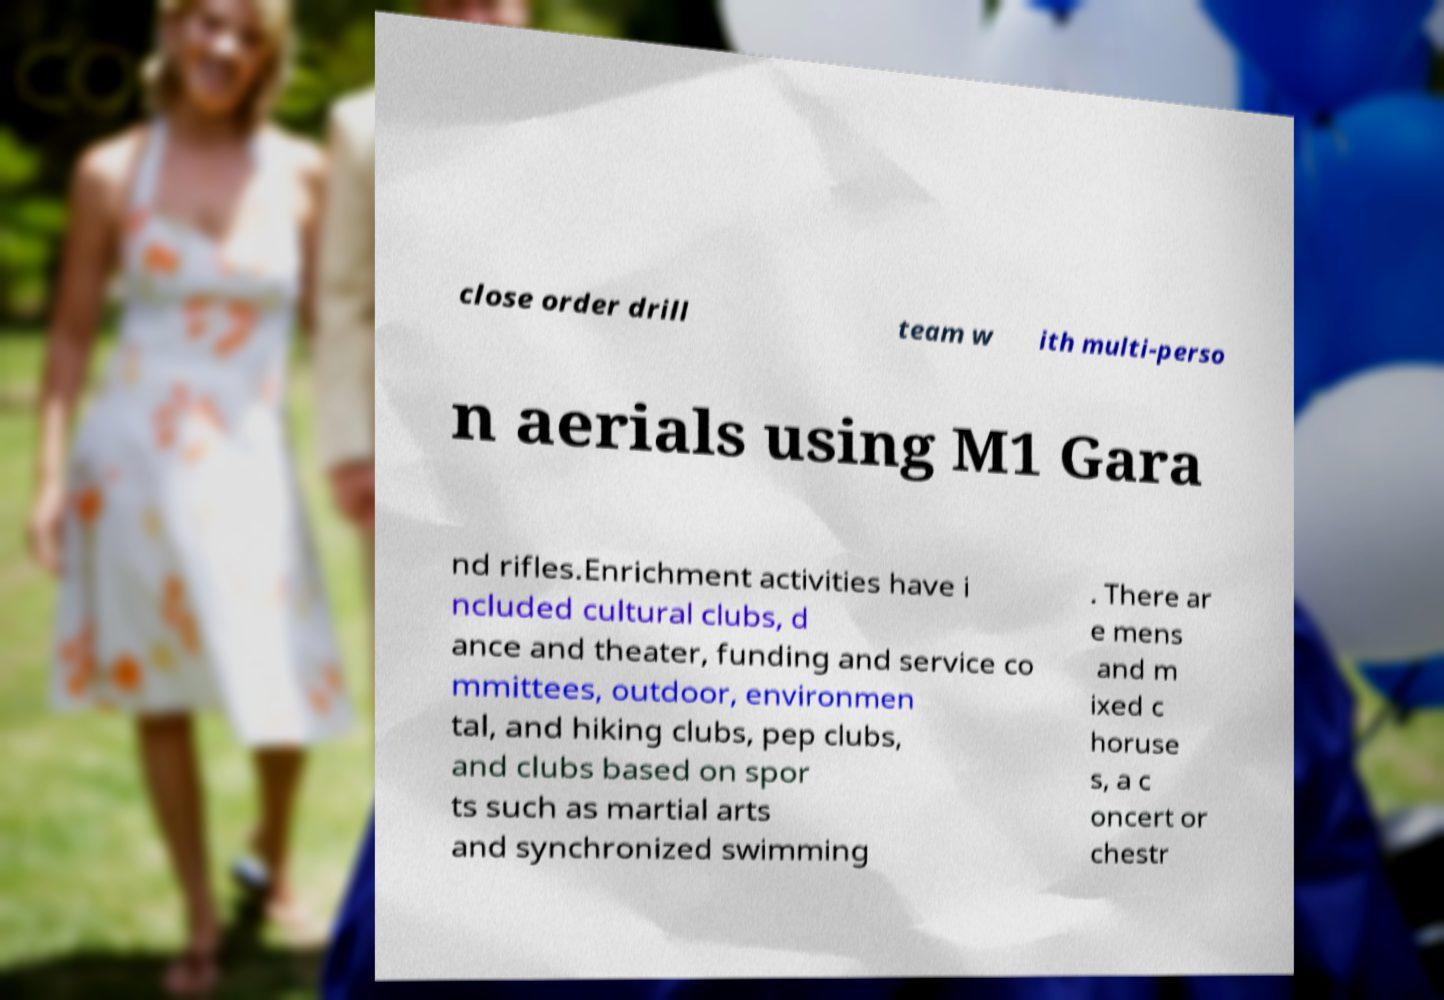Could you extract and type out the text from this image? close order drill team w ith multi-perso n aerials using M1 Gara nd rifles.Enrichment activities have i ncluded cultural clubs, d ance and theater, funding and service co mmittees, outdoor, environmen tal, and hiking clubs, pep clubs, and clubs based on spor ts such as martial arts and synchronized swimming . There ar e mens and m ixed c horuse s, a c oncert or chestr 